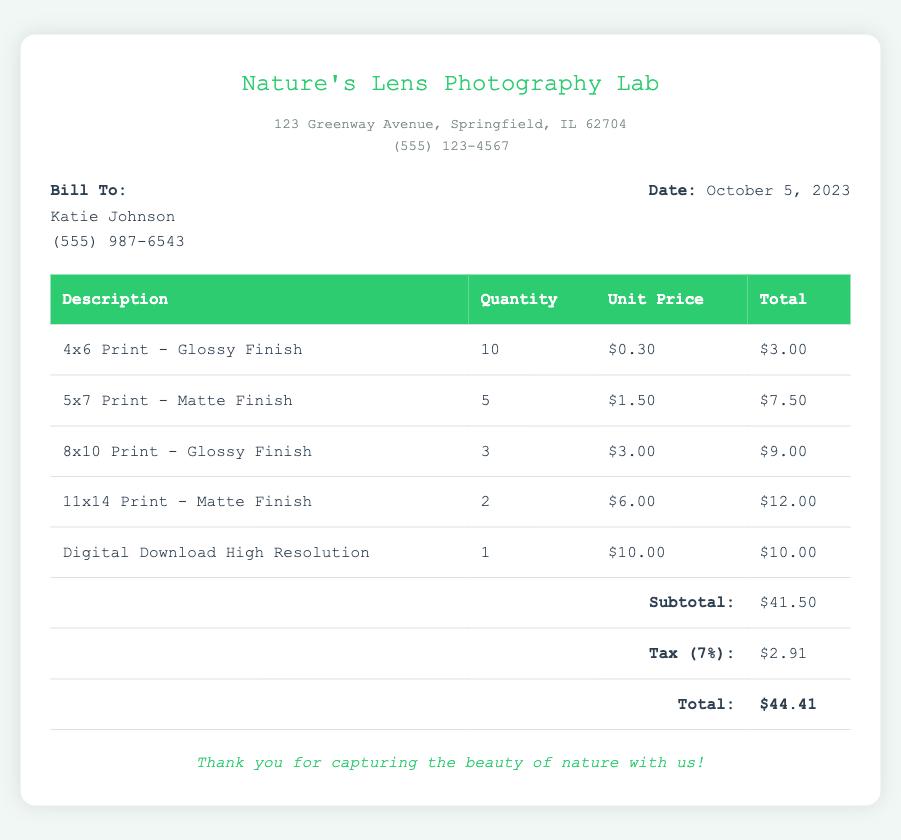What is the name of the photography lab? The name of the photography lab is listed at the top of the document.
Answer: Nature's Lens Photography Lab Who is the bill addressed to? The document specifies the customer’s name under the "Bill To" section.
Answer: Katie Johnson What is the date of the bill? The date is mentioned in the customer information section of the document.
Answer: October 5, 2023 How many 4x6 prints were ordered? The quantity of 4x6 prints can be found in the table of descriptions.
Answer: 10 What is the total amount due on the bill? The total amount is calculated at the bottom of the table as the final figure.
Answer: $44.41 What is the unit price of an 8x10 print with glossy finish? The unit price for this specific print is stated in the order details of the table.
Answer: $3.00 What is the subtotal amount before tax? The subtotal is presented in the table as one of the line items.
Answer: $41.50 How much is the tax charged on the bill? The tax amount is detailed as a separate line item in the table below the subtotal.
Answer: $2.91 